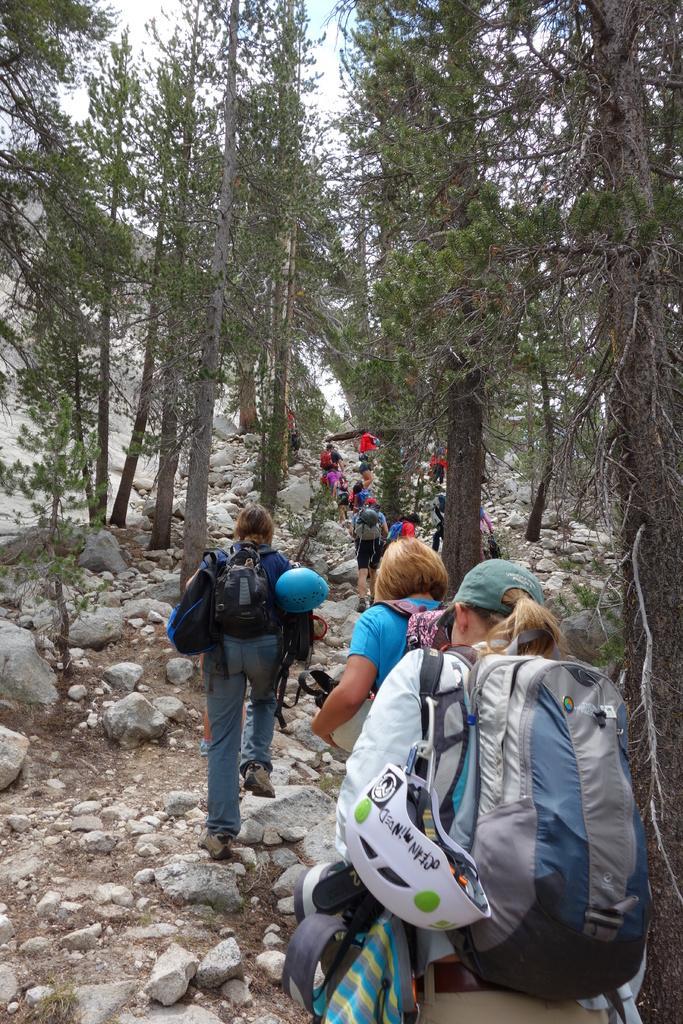In one or two sentences, can you explain what this image depicts? This image is clicked in trekking place, there are trees on the top of the image. And there persons who are trekking are there in the image. two women are in the middle of the image. And one woman is also in the middle of the image and there are rocks on the right, left side corner. All people are holdings bags and helmets caps. 